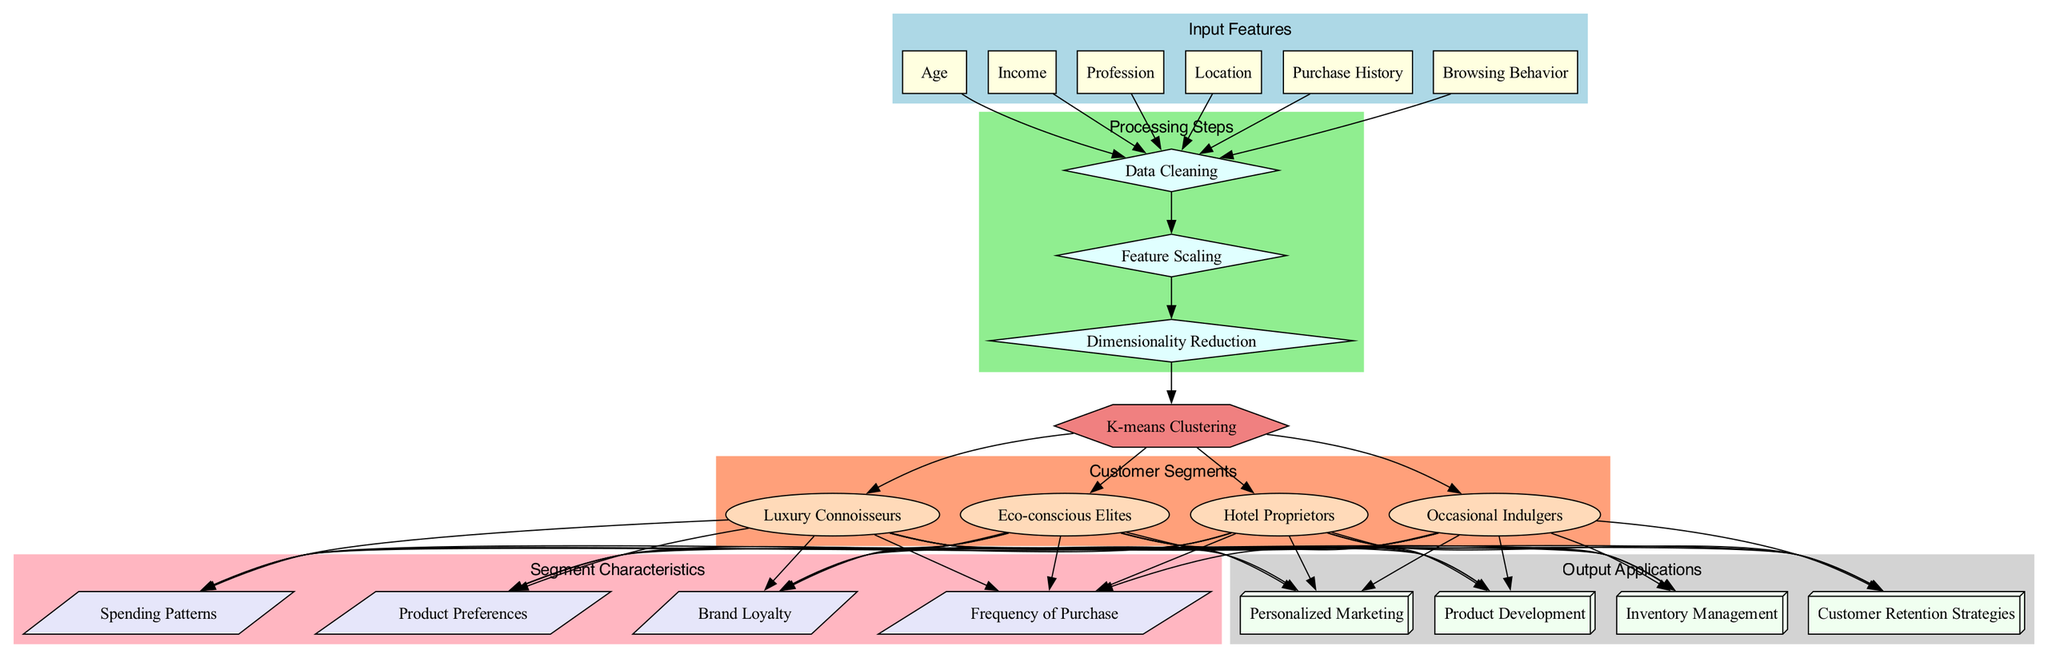What are the input features used in the model? The diagram lists six input features, which are Age, Income, Profession, Location, Purchase History, and Browsing Behavior. These are categorized under the 'Input Features' section of the diagram.
Answer: Age, Income, Profession, Location, Purchase History, Browsing Behavior How many customer segments are defined in the model? The diagram indicates that there are four distinct customer segments, which are Luxury Connoisseurs, Eco-conscious Elites, Hotel Proprietors, and Occasional Indulgers. This can be counted from the 'Customer Segments' section.
Answer: 4 What is the processing step that comes after Data Cleaning? The diagram shows a sequence of processing steps. Data Cleaning is followed directly by Feature Scaling as evident from the flow of edges connecting the steps sequentially.
Answer: Feature Scaling Which segmentation model is utilized in this diagram? The diagram highlights a single model used in the segmentation process, which is K-means Clustering, as noted in the 'Segmentation Model' section of the diagram.
Answer: K-means Clustering What are the output applications of the customer segmentation model? The diagram lists four output applications which include Personalized Marketing, Product Development, Inventory Management, and Customer Retention Strategies under the 'Output Applications' section.
Answer: Personalized Marketing, Product Development, Inventory Management, Customer Retention Strategies How does the segmentation model connect to customer segments? The diagram shows that the segmentation model connects to each of the customer segments through edges that indicate the flow from the model to the segments, highlighting the model's role in defining these segments.
Answer: Through edges What characteristics are associated with customer segments? The diagram specifies four characteristics associated with customer segments, which are Spending Patterns, Product Preferences, Brand Loyalty, and Frequency of Purchase. This information can be found in the 'Segment Characteristics' section of the diagram.
Answer: Spending Patterns, Product Preferences, Brand Loyalty, Frequency of Purchase What type of diagram is presented here? The diagram is categorized as a Machine Learning Diagram, specifically focusing on a customer segmentation model for luxury linen buyers, which is indicated in the comment of the directed graph.
Answer: Machine Learning Diagram How many processing steps are there in the model? The diagram outlines three distinct processing steps: Data Cleaning, Feature Scaling, and Dimensionality Reduction. This can be counted from the 'Processing Steps' section of the diagram.
Answer: 3 